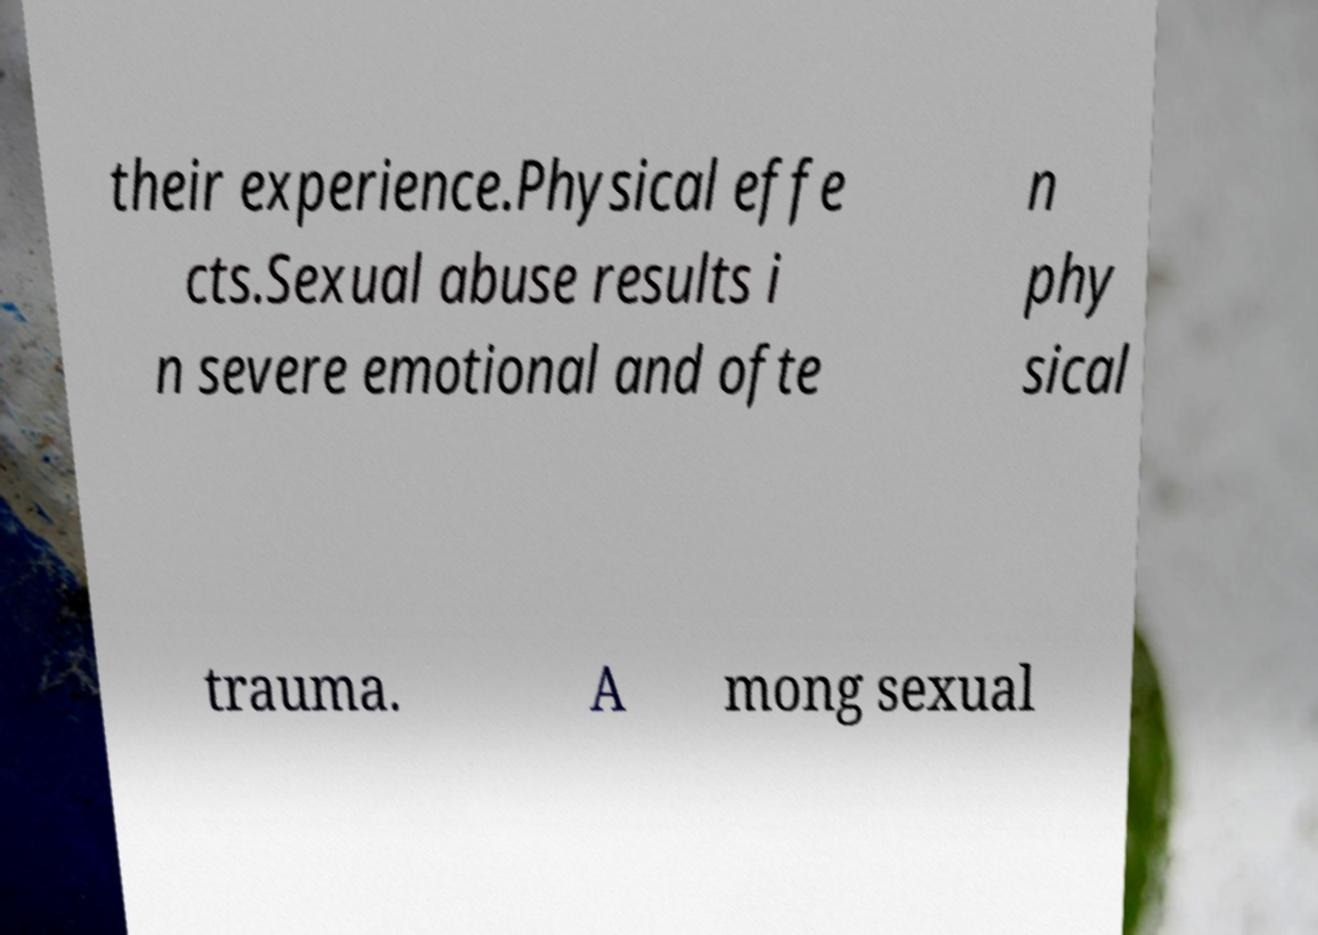What messages or text are displayed in this image? I need them in a readable, typed format. their experience.Physical effe cts.Sexual abuse results i n severe emotional and ofte n phy sical trauma. A mong sexual 